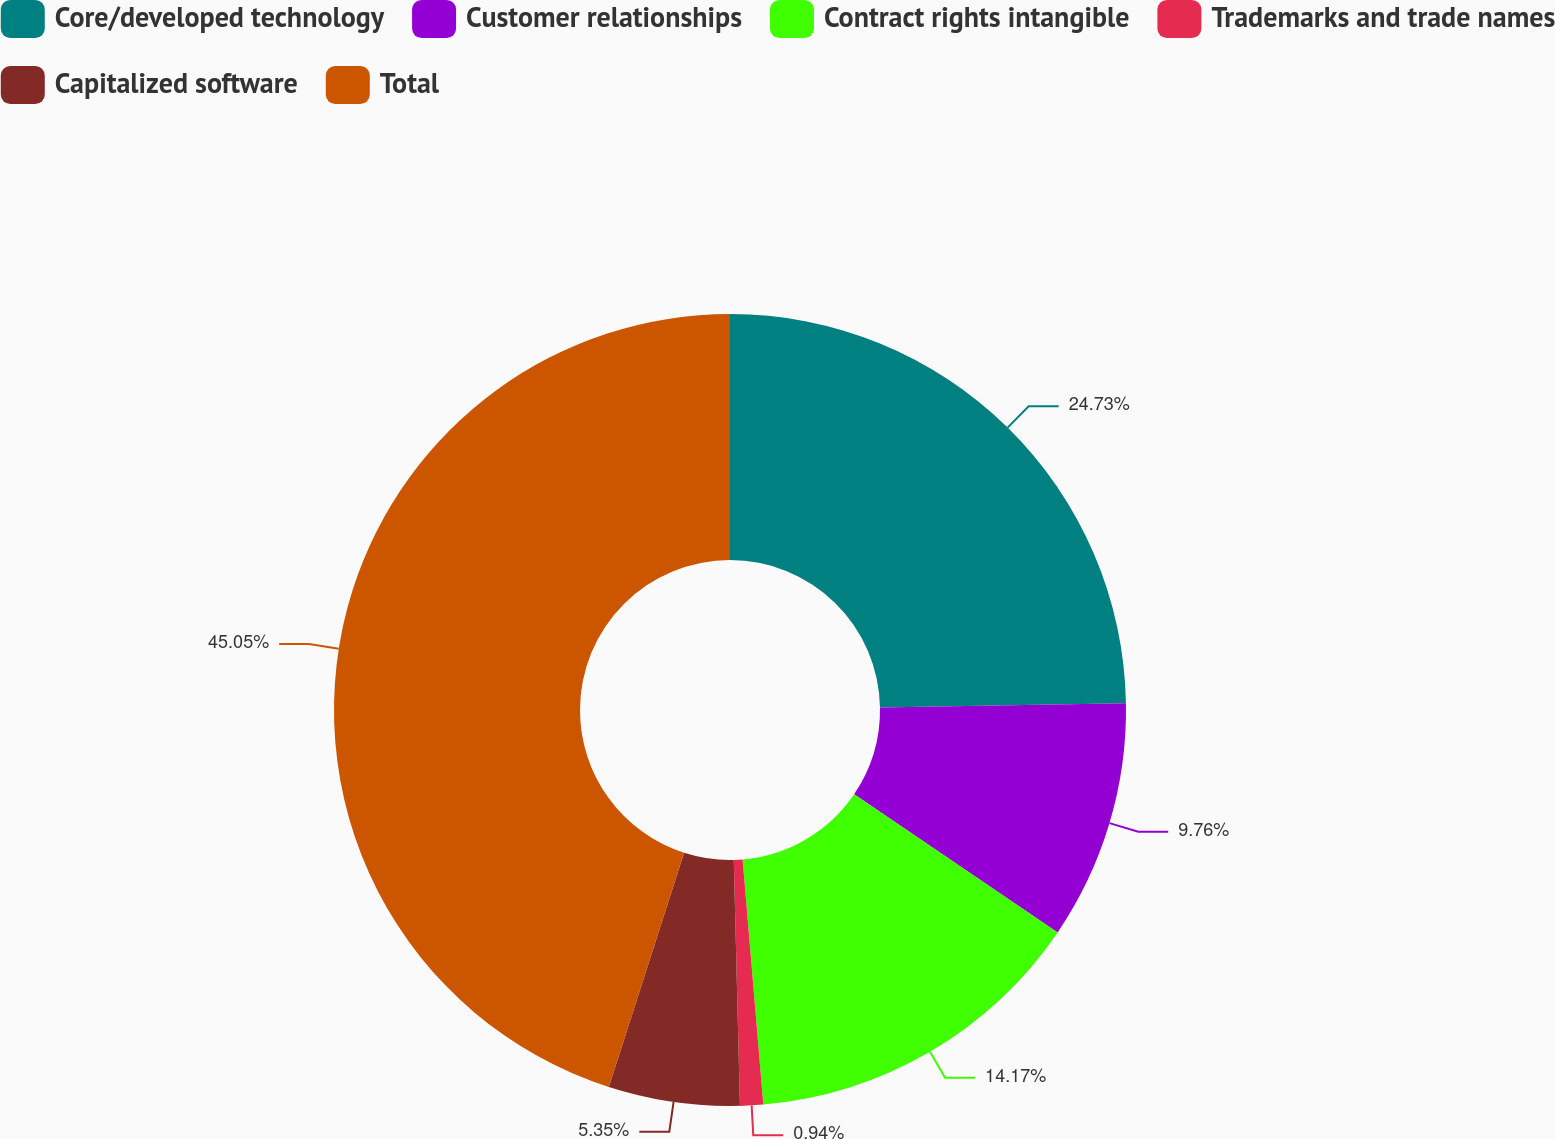Convert chart to OTSL. <chart><loc_0><loc_0><loc_500><loc_500><pie_chart><fcel>Core/developed technology<fcel>Customer relationships<fcel>Contract rights intangible<fcel>Trademarks and trade names<fcel>Capitalized software<fcel>Total<nl><fcel>24.73%<fcel>9.76%<fcel>14.17%<fcel>0.94%<fcel>5.35%<fcel>45.05%<nl></chart> 